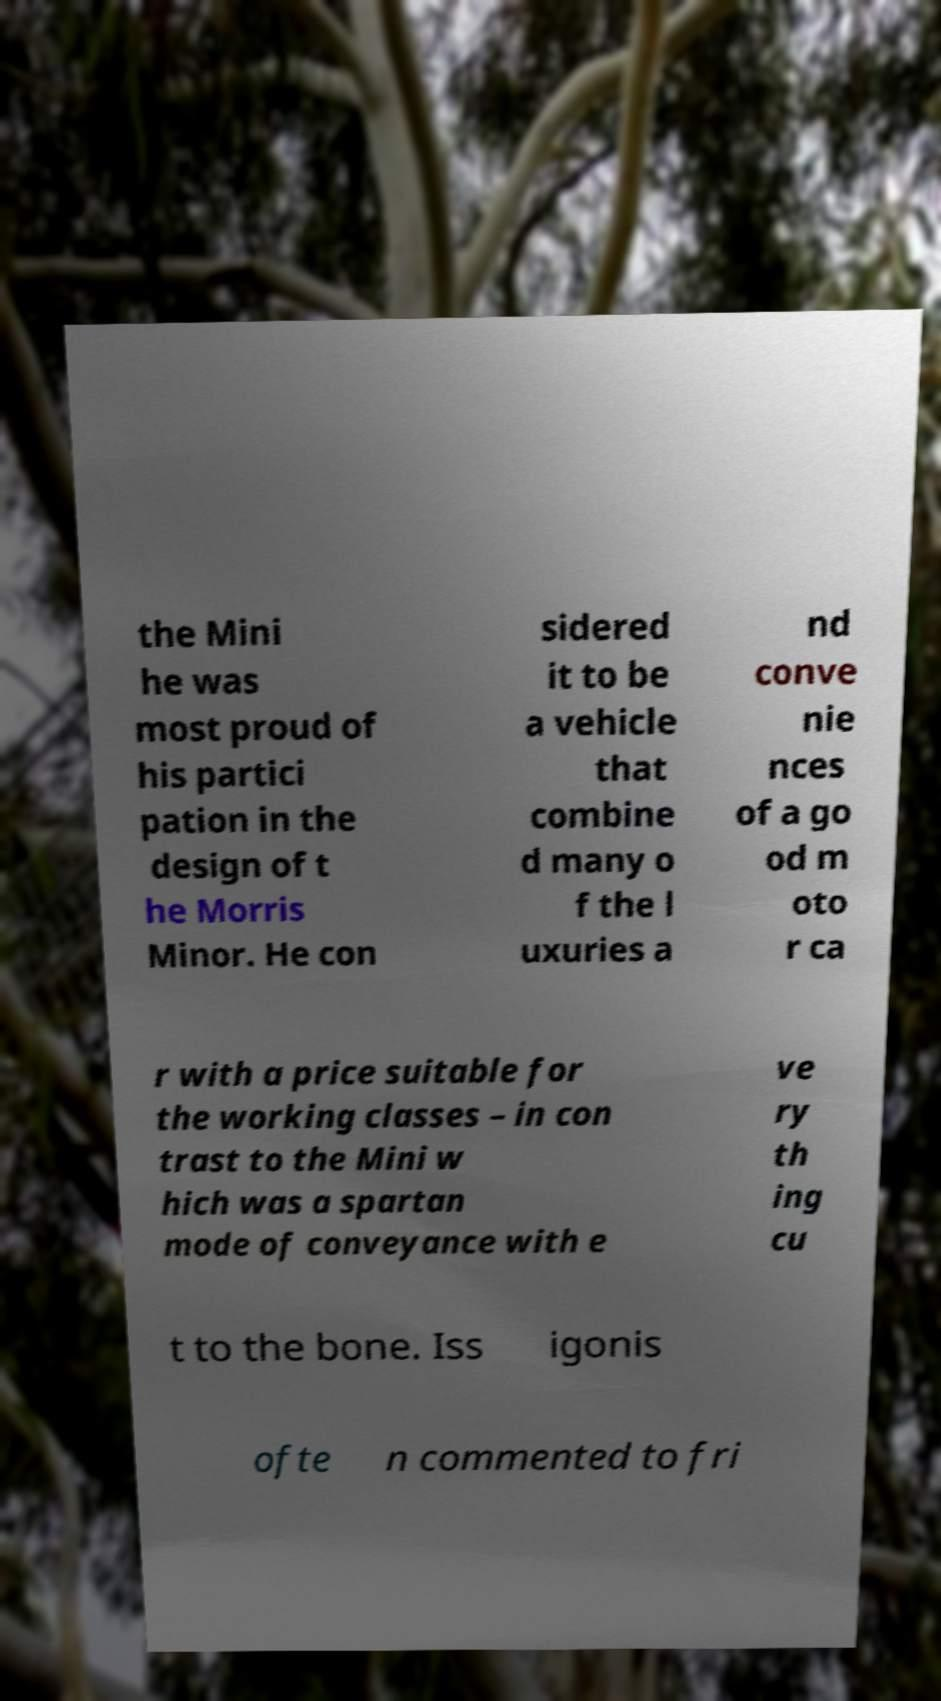For documentation purposes, I need the text within this image transcribed. Could you provide that? the Mini he was most proud of his partici pation in the design of t he Morris Minor. He con sidered it to be a vehicle that combine d many o f the l uxuries a nd conve nie nces of a go od m oto r ca r with a price suitable for the working classes – in con trast to the Mini w hich was a spartan mode of conveyance with e ve ry th ing cu t to the bone. Iss igonis ofte n commented to fri 